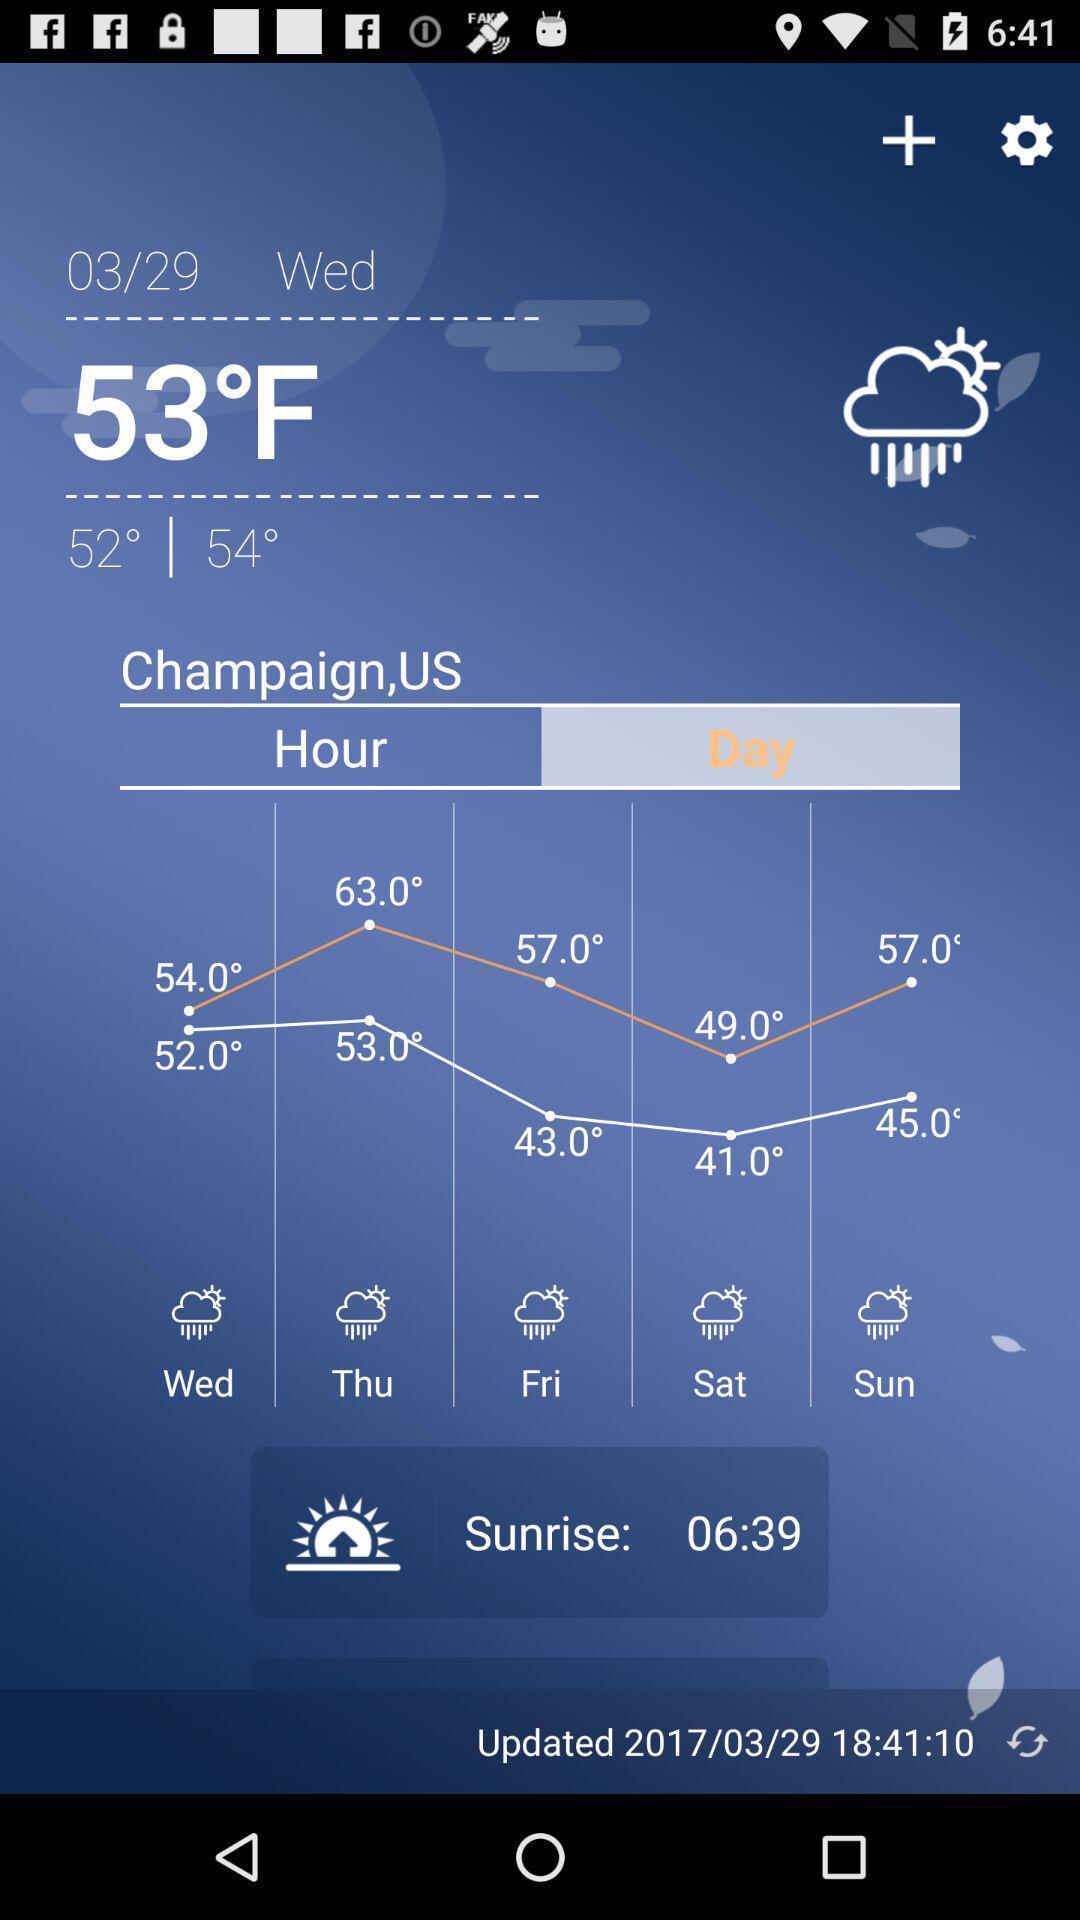What can you discern from this picture? Various weather forecast displayed. 